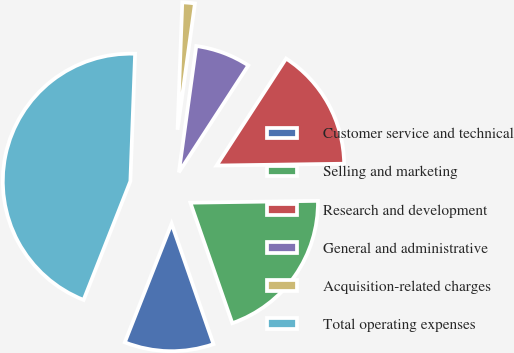Convert chart. <chart><loc_0><loc_0><loc_500><loc_500><pie_chart><fcel>Customer service and technical<fcel>Selling and marketing<fcel>Research and development<fcel>General and administrative<fcel>Acquisition-related charges<fcel>Total operating expenses<nl><fcel>11.3%<fcel>19.9%<fcel>15.6%<fcel>6.99%<fcel>1.59%<fcel>44.61%<nl></chart> 